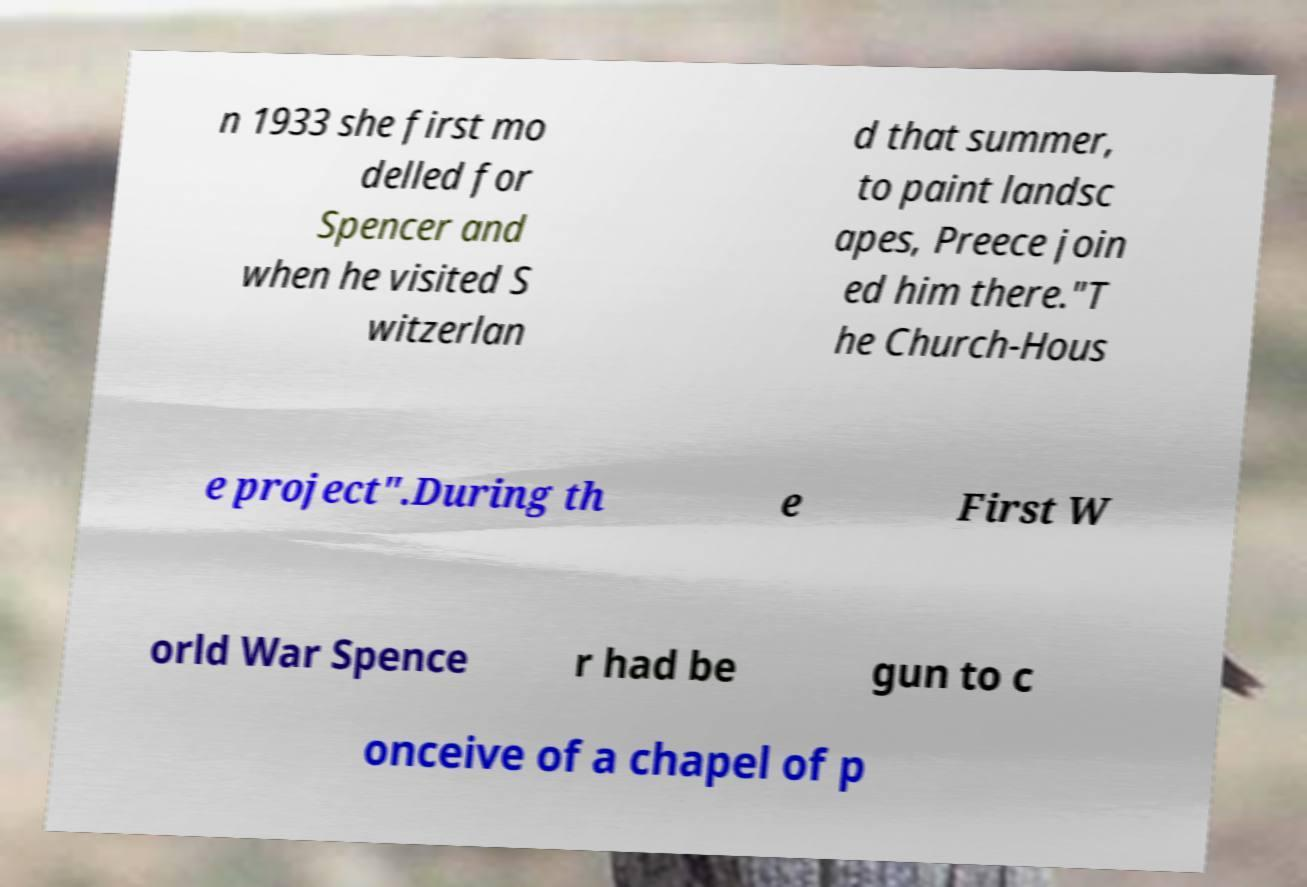Can you read and provide the text displayed in the image?This photo seems to have some interesting text. Can you extract and type it out for me? n 1933 she first mo delled for Spencer and when he visited S witzerlan d that summer, to paint landsc apes, Preece join ed him there."T he Church-Hous e project".During th e First W orld War Spence r had be gun to c onceive of a chapel of p 